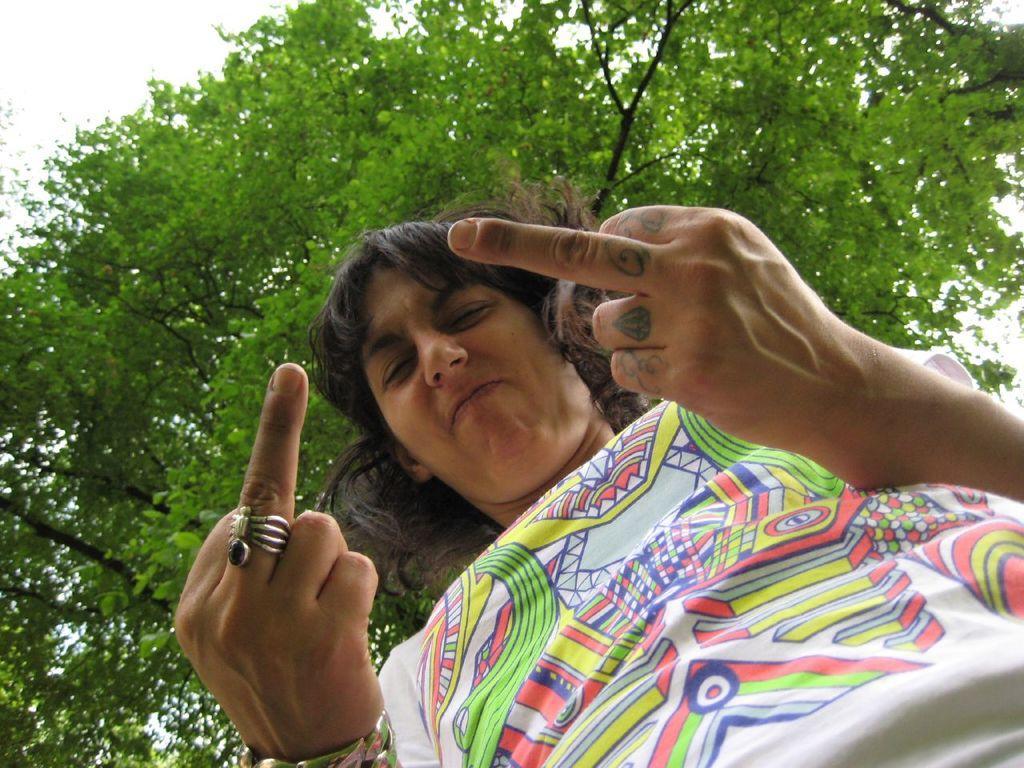In one or two sentences, can you explain what this image depicts? In this image there is a person showing some gesture with his figures. Behind him there are trees and sky. 